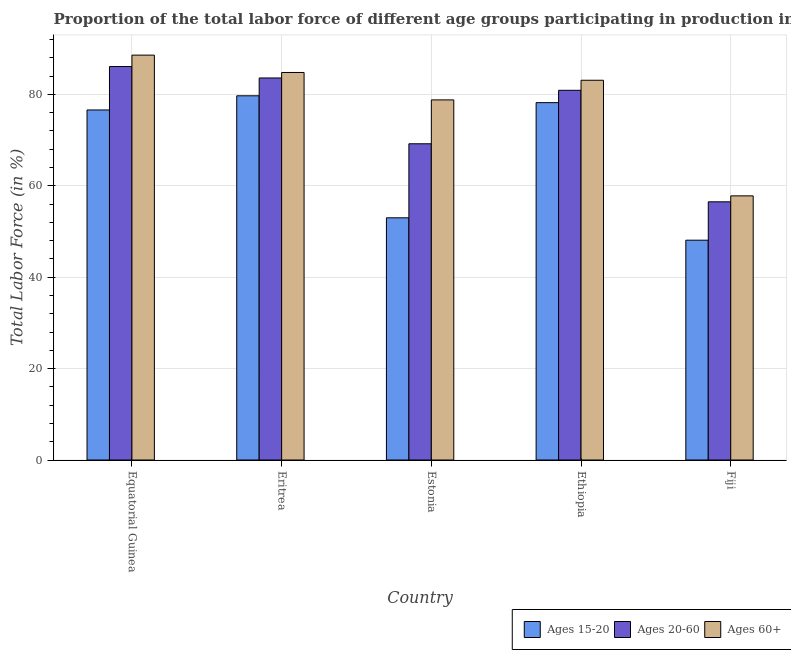How many bars are there on the 3rd tick from the left?
Keep it short and to the point. 3. What is the label of the 5th group of bars from the left?
Offer a very short reply. Fiji. What is the percentage of labor force within the age group 20-60 in Eritrea?
Give a very brief answer. 83.6. Across all countries, what is the maximum percentage of labor force above age 60?
Offer a very short reply. 88.6. Across all countries, what is the minimum percentage of labor force within the age group 20-60?
Provide a short and direct response. 56.5. In which country was the percentage of labor force within the age group 15-20 maximum?
Your response must be concise. Eritrea. In which country was the percentage of labor force within the age group 20-60 minimum?
Ensure brevity in your answer.  Fiji. What is the total percentage of labor force within the age group 20-60 in the graph?
Provide a succinct answer. 376.3. What is the difference between the percentage of labor force within the age group 15-20 in Eritrea and that in Ethiopia?
Provide a succinct answer. 1.5. What is the difference between the percentage of labor force above age 60 in Fiji and the percentage of labor force within the age group 15-20 in Equatorial Guinea?
Make the answer very short. -18.8. What is the average percentage of labor force within the age group 15-20 per country?
Keep it short and to the point. 67.12. What is the difference between the percentage of labor force above age 60 and percentage of labor force within the age group 15-20 in Eritrea?
Keep it short and to the point. 5.1. What is the ratio of the percentage of labor force within the age group 20-60 in Equatorial Guinea to that in Ethiopia?
Your answer should be compact. 1.06. Is the difference between the percentage of labor force above age 60 in Eritrea and Ethiopia greater than the difference between the percentage of labor force within the age group 15-20 in Eritrea and Ethiopia?
Provide a short and direct response. Yes. What is the difference between the highest and the second highest percentage of labor force within the age group 15-20?
Give a very brief answer. 1.5. What is the difference between the highest and the lowest percentage of labor force above age 60?
Provide a succinct answer. 30.8. In how many countries, is the percentage of labor force above age 60 greater than the average percentage of labor force above age 60 taken over all countries?
Provide a short and direct response. 4. Is the sum of the percentage of labor force within the age group 20-60 in Equatorial Guinea and Ethiopia greater than the maximum percentage of labor force within the age group 15-20 across all countries?
Keep it short and to the point. Yes. What does the 2nd bar from the left in Eritrea represents?
Ensure brevity in your answer.  Ages 20-60. What does the 3rd bar from the right in Equatorial Guinea represents?
Provide a succinct answer. Ages 15-20. How many bars are there?
Provide a short and direct response. 15. How many countries are there in the graph?
Keep it short and to the point. 5. How many legend labels are there?
Ensure brevity in your answer.  3. How are the legend labels stacked?
Keep it short and to the point. Horizontal. What is the title of the graph?
Provide a short and direct response. Proportion of the total labor force of different age groups participating in production in 1990. Does "Renewable sources" appear as one of the legend labels in the graph?
Offer a terse response. No. What is the label or title of the X-axis?
Your answer should be very brief. Country. What is the Total Labor Force (in %) of Ages 15-20 in Equatorial Guinea?
Offer a terse response. 76.6. What is the Total Labor Force (in %) in Ages 20-60 in Equatorial Guinea?
Provide a succinct answer. 86.1. What is the Total Labor Force (in %) in Ages 60+ in Equatorial Guinea?
Ensure brevity in your answer.  88.6. What is the Total Labor Force (in %) of Ages 15-20 in Eritrea?
Ensure brevity in your answer.  79.7. What is the Total Labor Force (in %) in Ages 20-60 in Eritrea?
Give a very brief answer. 83.6. What is the Total Labor Force (in %) of Ages 60+ in Eritrea?
Keep it short and to the point. 84.8. What is the Total Labor Force (in %) in Ages 20-60 in Estonia?
Make the answer very short. 69.2. What is the Total Labor Force (in %) in Ages 60+ in Estonia?
Give a very brief answer. 78.8. What is the Total Labor Force (in %) of Ages 15-20 in Ethiopia?
Offer a very short reply. 78.2. What is the Total Labor Force (in %) of Ages 20-60 in Ethiopia?
Give a very brief answer. 80.9. What is the Total Labor Force (in %) in Ages 60+ in Ethiopia?
Provide a short and direct response. 83.1. What is the Total Labor Force (in %) in Ages 15-20 in Fiji?
Offer a terse response. 48.1. What is the Total Labor Force (in %) of Ages 20-60 in Fiji?
Offer a terse response. 56.5. What is the Total Labor Force (in %) of Ages 60+ in Fiji?
Provide a succinct answer. 57.8. Across all countries, what is the maximum Total Labor Force (in %) in Ages 15-20?
Make the answer very short. 79.7. Across all countries, what is the maximum Total Labor Force (in %) of Ages 20-60?
Your answer should be very brief. 86.1. Across all countries, what is the maximum Total Labor Force (in %) in Ages 60+?
Your response must be concise. 88.6. Across all countries, what is the minimum Total Labor Force (in %) of Ages 15-20?
Offer a very short reply. 48.1. Across all countries, what is the minimum Total Labor Force (in %) of Ages 20-60?
Make the answer very short. 56.5. Across all countries, what is the minimum Total Labor Force (in %) in Ages 60+?
Make the answer very short. 57.8. What is the total Total Labor Force (in %) in Ages 15-20 in the graph?
Provide a succinct answer. 335.6. What is the total Total Labor Force (in %) in Ages 20-60 in the graph?
Provide a succinct answer. 376.3. What is the total Total Labor Force (in %) in Ages 60+ in the graph?
Keep it short and to the point. 393.1. What is the difference between the Total Labor Force (in %) of Ages 15-20 in Equatorial Guinea and that in Estonia?
Ensure brevity in your answer.  23.6. What is the difference between the Total Labor Force (in %) of Ages 15-20 in Equatorial Guinea and that in Ethiopia?
Provide a succinct answer. -1.6. What is the difference between the Total Labor Force (in %) of Ages 20-60 in Equatorial Guinea and that in Ethiopia?
Offer a very short reply. 5.2. What is the difference between the Total Labor Force (in %) in Ages 15-20 in Equatorial Guinea and that in Fiji?
Offer a very short reply. 28.5. What is the difference between the Total Labor Force (in %) in Ages 20-60 in Equatorial Guinea and that in Fiji?
Offer a terse response. 29.6. What is the difference between the Total Labor Force (in %) in Ages 60+ in Equatorial Guinea and that in Fiji?
Keep it short and to the point. 30.8. What is the difference between the Total Labor Force (in %) in Ages 15-20 in Eritrea and that in Estonia?
Give a very brief answer. 26.7. What is the difference between the Total Labor Force (in %) of Ages 60+ in Eritrea and that in Ethiopia?
Give a very brief answer. 1.7. What is the difference between the Total Labor Force (in %) in Ages 15-20 in Eritrea and that in Fiji?
Your response must be concise. 31.6. What is the difference between the Total Labor Force (in %) in Ages 20-60 in Eritrea and that in Fiji?
Give a very brief answer. 27.1. What is the difference between the Total Labor Force (in %) of Ages 15-20 in Estonia and that in Ethiopia?
Give a very brief answer. -25.2. What is the difference between the Total Labor Force (in %) of Ages 15-20 in Estonia and that in Fiji?
Offer a very short reply. 4.9. What is the difference between the Total Labor Force (in %) in Ages 20-60 in Estonia and that in Fiji?
Give a very brief answer. 12.7. What is the difference between the Total Labor Force (in %) in Ages 60+ in Estonia and that in Fiji?
Offer a terse response. 21. What is the difference between the Total Labor Force (in %) of Ages 15-20 in Ethiopia and that in Fiji?
Offer a terse response. 30.1. What is the difference between the Total Labor Force (in %) in Ages 20-60 in Ethiopia and that in Fiji?
Make the answer very short. 24.4. What is the difference between the Total Labor Force (in %) of Ages 60+ in Ethiopia and that in Fiji?
Your answer should be very brief. 25.3. What is the difference between the Total Labor Force (in %) of Ages 15-20 in Equatorial Guinea and the Total Labor Force (in %) of Ages 20-60 in Eritrea?
Give a very brief answer. -7. What is the difference between the Total Labor Force (in %) in Ages 20-60 in Equatorial Guinea and the Total Labor Force (in %) in Ages 60+ in Eritrea?
Give a very brief answer. 1.3. What is the difference between the Total Labor Force (in %) in Ages 20-60 in Equatorial Guinea and the Total Labor Force (in %) in Ages 60+ in Estonia?
Your answer should be compact. 7.3. What is the difference between the Total Labor Force (in %) of Ages 15-20 in Equatorial Guinea and the Total Labor Force (in %) of Ages 20-60 in Ethiopia?
Provide a succinct answer. -4.3. What is the difference between the Total Labor Force (in %) of Ages 20-60 in Equatorial Guinea and the Total Labor Force (in %) of Ages 60+ in Ethiopia?
Make the answer very short. 3. What is the difference between the Total Labor Force (in %) of Ages 15-20 in Equatorial Guinea and the Total Labor Force (in %) of Ages 20-60 in Fiji?
Keep it short and to the point. 20.1. What is the difference between the Total Labor Force (in %) in Ages 20-60 in Equatorial Guinea and the Total Labor Force (in %) in Ages 60+ in Fiji?
Give a very brief answer. 28.3. What is the difference between the Total Labor Force (in %) in Ages 15-20 in Eritrea and the Total Labor Force (in %) in Ages 20-60 in Fiji?
Offer a very short reply. 23.2. What is the difference between the Total Labor Force (in %) in Ages 15-20 in Eritrea and the Total Labor Force (in %) in Ages 60+ in Fiji?
Your answer should be very brief. 21.9. What is the difference between the Total Labor Force (in %) in Ages 20-60 in Eritrea and the Total Labor Force (in %) in Ages 60+ in Fiji?
Provide a short and direct response. 25.8. What is the difference between the Total Labor Force (in %) of Ages 15-20 in Estonia and the Total Labor Force (in %) of Ages 20-60 in Ethiopia?
Make the answer very short. -27.9. What is the difference between the Total Labor Force (in %) in Ages 15-20 in Estonia and the Total Labor Force (in %) in Ages 60+ in Ethiopia?
Your response must be concise. -30.1. What is the difference between the Total Labor Force (in %) of Ages 20-60 in Estonia and the Total Labor Force (in %) of Ages 60+ in Ethiopia?
Ensure brevity in your answer.  -13.9. What is the difference between the Total Labor Force (in %) in Ages 15-20 in Estonia and the Total Labor Force (in %) in Ages 60+ in Fiji?
Give a very brief answer. -4.8. What is the difference between the Total Labor Force (in %) of Ages 20-60 in Estonia and the Total Labor Force (in %) of Ages 60+ in Fiji?
Provide a short and direct response. 11.4. What is the difference between the Total Labor Force (in %) in Ages 15-20 in Ethiopia and the Total Labor Force (in %) in Ages 20-60 in Fiji?
Offer a terse response. 21.7. What is the difference between the Total Labor Force (in %) of Ages 15-20 in Ethiopia and the Total Labor Force (in %) of Ages 60+ in Fiji?
Your answer should be compact. 20.4. What is the difference between the Total Labor Force (in %) in Ages 20-60 in Ethiopia and the Total Labor Force (in %) in Ages 60+ in Fiji?
Keep it short and to the point. 23.1. What is the average Total Labor Force (in %) in Ages 15-20 per country?
Your answer should be compact. 67.12. What is the average Total Labor Force (in %) in Ages 20-60 per country?
Keep it short and to the point. 75.26. What is the average Total Labor Force (in %) of Ages 60+ per country?
Provide a succinct answer. 78.62. What is the difference between the Total Labor Force (in %) in Ages 15-20 and Total Labor Force (in %) in Ages 20-60 in Equatorial Guinea?
Ensure brevity in your answer.  -9.5. What is the difference between the Total Labor Force (in %) in Ages 20-60 and Total Labor Force (in %) in Ages 60+ in Equatorial Guinea?
Your answer should be very brief. -2.5. What is the difference between the Total Labor Force (in %) in Ages 15-20 and Total Labor Force (in %) in Ages 20-60 in Eritrea?
Offer a very short reply. -3.9. What is the difference between the Total Labor Force (in %) in Ages 15-20 and Total Labor Force (in %) in Ages 60+ in Eritrea?
Your answer should be very brief. -5.1. What is the difference between the Total Labor Force (in %) of Ages 20-60 and Total Labor Force (in %) of Ages 60+ in Eritrea?
Your response must be concise. -1.2. What is the difference between the Total Labor Force (in %) in Ages 15-20 and Total Labor Force (in %) in Ages 20-60 in Estonia?
Your answer should be very brief. -16.2. What is the difference between the Total Labor Force (in %) of Ages 15-20 and Total Labor Force (in %) of Ages 60+ in Estonia?
Provide a short and direct response. -25.8. What is the difference between the Total Labor Force (in %) in Ages 20-60 and Total Labor Force (in %) in Ages 60+ in Ethiopia?
Give a very brief answer. -2.2. What is the ratio of the Total Labor Force (in %) in Ages 15-20 in Equatorial Guinea to that in Eritrea?
Offer a very short reply. 0.96. What is the ratio of the Total Labor Force (in %) of Ages 20-60 in Equatorial Guinea to that in Eritrea?
Your response must be concise. 1.03. What is the ratio of the Total Labor Force (in %) in Ages 60+ in Equatorial Guinea to that in Eritrea?
Your response must be concise. 1.04. What is the ratio of the Total Labor Force (in %) in Ages 15-20 in Equatorial Guinea to that in Estonia?
Your answer should be very brief. 1.45. What is the ratio of the Total Labor Force (in %) in Ages 20-60 in Equatorial Guinea to that in Estonia?
Offer a terse response. 1.24. What is the ratio of the Total Labor Force (in %) of Ages 60+ in Equatorial Guinea to that in Estonia?
Give a very brief answer. 1.12. What is the ratio of the Total Labor Force (in %) in Ages 15-20 in Equatorial Guinea to that in Ethiopia?
Offer a terse response. 0.98. What is the ratio of the Total Labor Force (in %) of Ages 20-60 in Equatorial Guinea to that in Ethiopia?
Offer a very short reply. 1.06. What is the ratio of the Total Labor Force (in %) in Ages 60+ in Equatorial Guinea to that in Ethiopia?
Provide a short and direct response. 1.07. What is the ratio of the Total Labor Force (in %) in Ages 15-20 in Equatorial Guinea to that in Fiji?
Offer a terse response. 1.59. What is the ratio of the Total Labor Force (in %) in Ages 20-60 in Equatorial Guinea to that in Fiji?
Your answer should be compact. 1.52. What is the ratio of the Total Labor Force (in %) of Ages 60+ in Equatorial Guinea to that in Fiji?
Offer a terse response. 1.53. What is the ratio of the Total Labor Force (in %) in Ages 15-20 in Eritrea to that in Estonia?
Offer a very short reply. 1.5. What is the ratio of the Total Labor Force (in %) in Ages 20-60 in Eritrea to that in Estonia?
Give a very brief answer. 1.21. What is the ratio of the Total Labor Force (in %) in Ages 60+ in Eritrea to that in Estonia?
Provide a succinct answer. 1.08. What is the ratio of the Total Labor Force (in %) of Ages 15-20 in Eritrea to that in Ethiopia?
Provide a succinct answer. 1.02. What is the ratio of the Total Labor Force (in %) of Ages 20-60 in Eritrea to that in Ethiopia?
Offer a very short reply. 1.03. What is the ratio of the Total Labor Force (in %) in Ages 60+ in Eritrea to that in Ethiopia?
Offer a terse response. 1.02. What is the ratio of the Total Labor Force (in %) in Ages 15-20 in Eritrea to that in Fiji?
Ensure brevity in your answer.  1.66. What is the ratio of the Total Labor Force (in %) in Ages 20-60 in Eritrea to that in Fiji?
Ensure brevity in your answer.  1.48. What is the ratio of the Total Labor Force (in %) of Ages 60+ in Eritrea to that in Fiji?
Ensure brevity in your answer.  1.47. What is the ratio of the Total Labor Force (in %) of Ages 15-20 in Estonia to that in Ethiopia?
Give a very brief answer. 0.68. What is the ratio of the Total Labor Force (in %) in Ages 20-60 in Estonia to that in Ethiopia?
Ensure brevity in your answer.  0.86. What is the ratio of the Total Labor Force (in %) in Ages 60+ in Estonia to that in Ethiopia?
Provide a succinct answer. 0.95. What is the ratio of the Total Labor Force (in %) of Ages 15-20 in Estonia to that in Fiji?
Make the answer very short. 1.1. What is the ratio of the Total Labor Force (in %) of Ages 20-60 in Estonia to that in Fiji?
Keep it short and to the point. 1.22. What is the ratio of the Total Labor Force (in %) in Ages 60+ in Estonia to that in Fiji?
Your response must be concise. 1.36. What is the ratio of the Total Labor Force (in %) in Ages 15-20 in Ethiopia to that in Fiji?
Offer a very short reply. 1.63. What is the ratio of the Total Labor Force (in %) of Ages 20-60 in Ethiopia to that in Fiji?
Offer a very short reply. 1.43. What is the ratio of the Total Labor Force (in %) of Ages 60+ in Ethiopia to that in Fiji?
Offer a very short reply. 1.44. What is the difference between the highest and the second highest Total Labor Force (in %) of Ages 15-20?
Provide a succinct answer. 1.5. What is the difference between the highest and the second highest Total Labor Force (in %) in Ages 20-60?
Keep it short and to the point. 2.5. What is the difference between the highest and the second highest Total Labor Force (in %) in Ages 60+?
Make the answer very short. 3.8. What is the difference between the highest and the lowest Total Labor Force (in %) of Ages 15-20?
Keep it short and to the point. 31.6. What is the difference between the highest and the lowest Total Labor Force (in %) in Ages 20-60?
Your response must be concise. 29.6. What is the difference between the highest and the lowest Total Labor Force (in %) of Ages 60+?
Offer a very short reply. 30.8. 